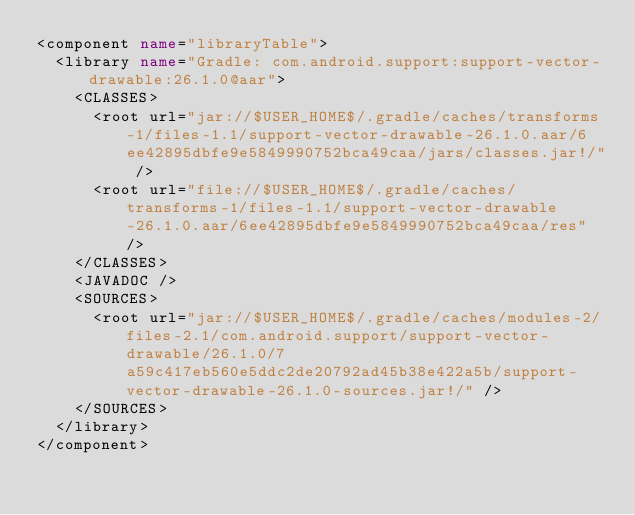<code> <loc_0><loc_0><loc_500><loc_500><_XML_><component name="libraryTable">
  <library name="Gradle: com.android.support:support-vector-drawable:26.1.0@aar">
    <CLASSES>
      <root url="jar://$USER_HOME$/.gradle/caches/transforms-1/files-1.1/support-vector-drawable-26.1.0.aar/6ee42895dbfe9e5849990752bca49caa/jars/classes.jar!/" />
      <root url="file://$USER_HOME$/.gradle/caches/transforms-1/files-1.1/support-vector-drawable-26.1.0.aar/6ee42895dbfe9e5849990752bca49caa/res" />
    </CLASSES>
    <JAVADOC />
    <SOURCES>
      <root url="jar://$USER_HOME$/.gradle/caches/modules-2/files-2.1/com.android.support/support-vector-drawable/26.1.0/7a59c417eb560e5ddc2de20792ad45b38e422a5b/support-vector-drawable-26.1.0-sources.jar!/" />
    </SOURCES>
  </library>
</component></code> 